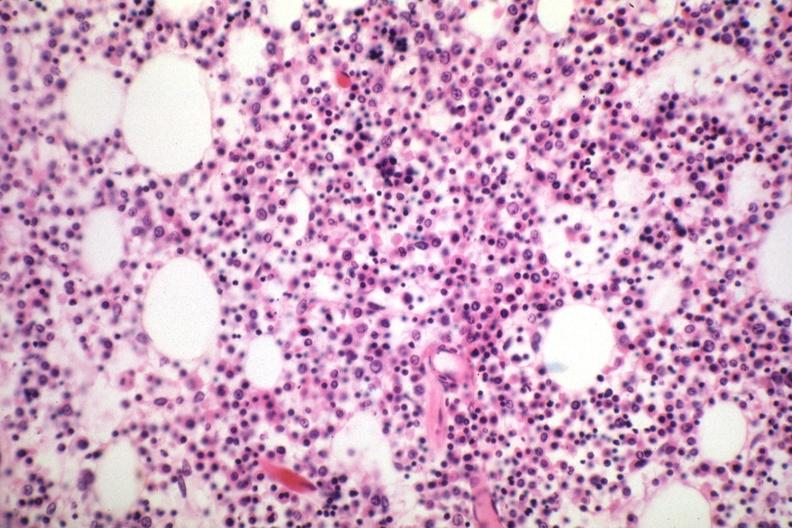what is present?
Answer the question using a single word or phrase. Multiple myeloma 